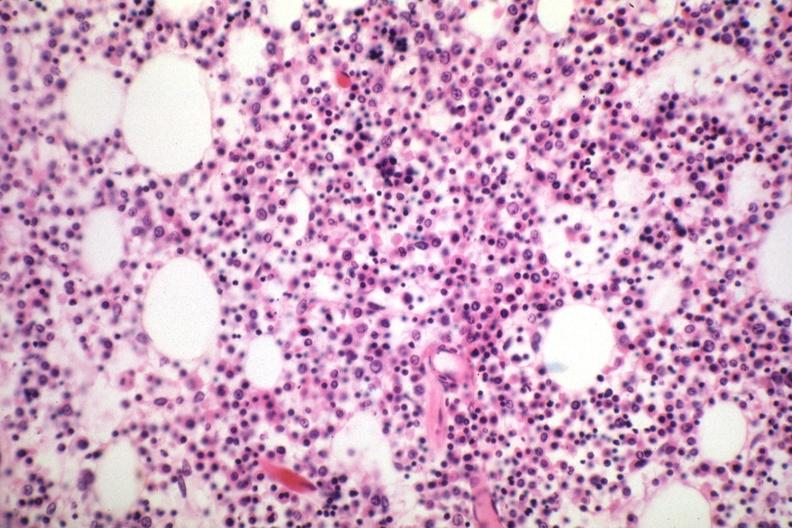what is present?
Answer the question using a single word or phrase. Multiple myeloma 